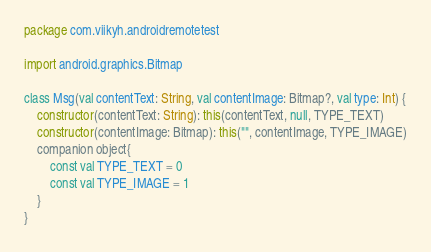Convert code to text. <code><loc_0><loc_0><loc_500><loc_500><_Kotlin_>package com.viikyh.androidremotetest

import android.graphics.Bitmap

class Msg(val contentText: String, val contentImage: Bitmap?, val type: Int) {
    constructor(contentText: String): this(contentText, null, TYPE_TEXT)
    constructor(contentImage: Bitmap): this("", contentImage, TYPE_IMAGE)
    companion object{
        const val TYPE_TEXT = 0
        const val TYPE_IMAGE = 1
    }
}</code> 